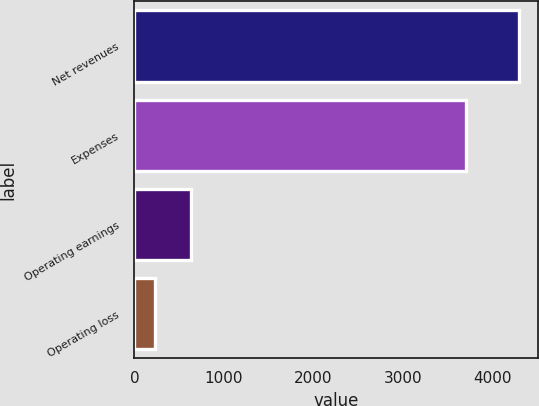Convert chart to OTSL. <chart><loc_0><loc_0><loc_500><loc_500><bar_chart><fcel>Net revenues<fcel>Expenses<fcel>Operating earnings<fcel>Operating loss<nl><fcel>4295<fcel>3703<fcel>635.6<fcel>229<nl></chart> 